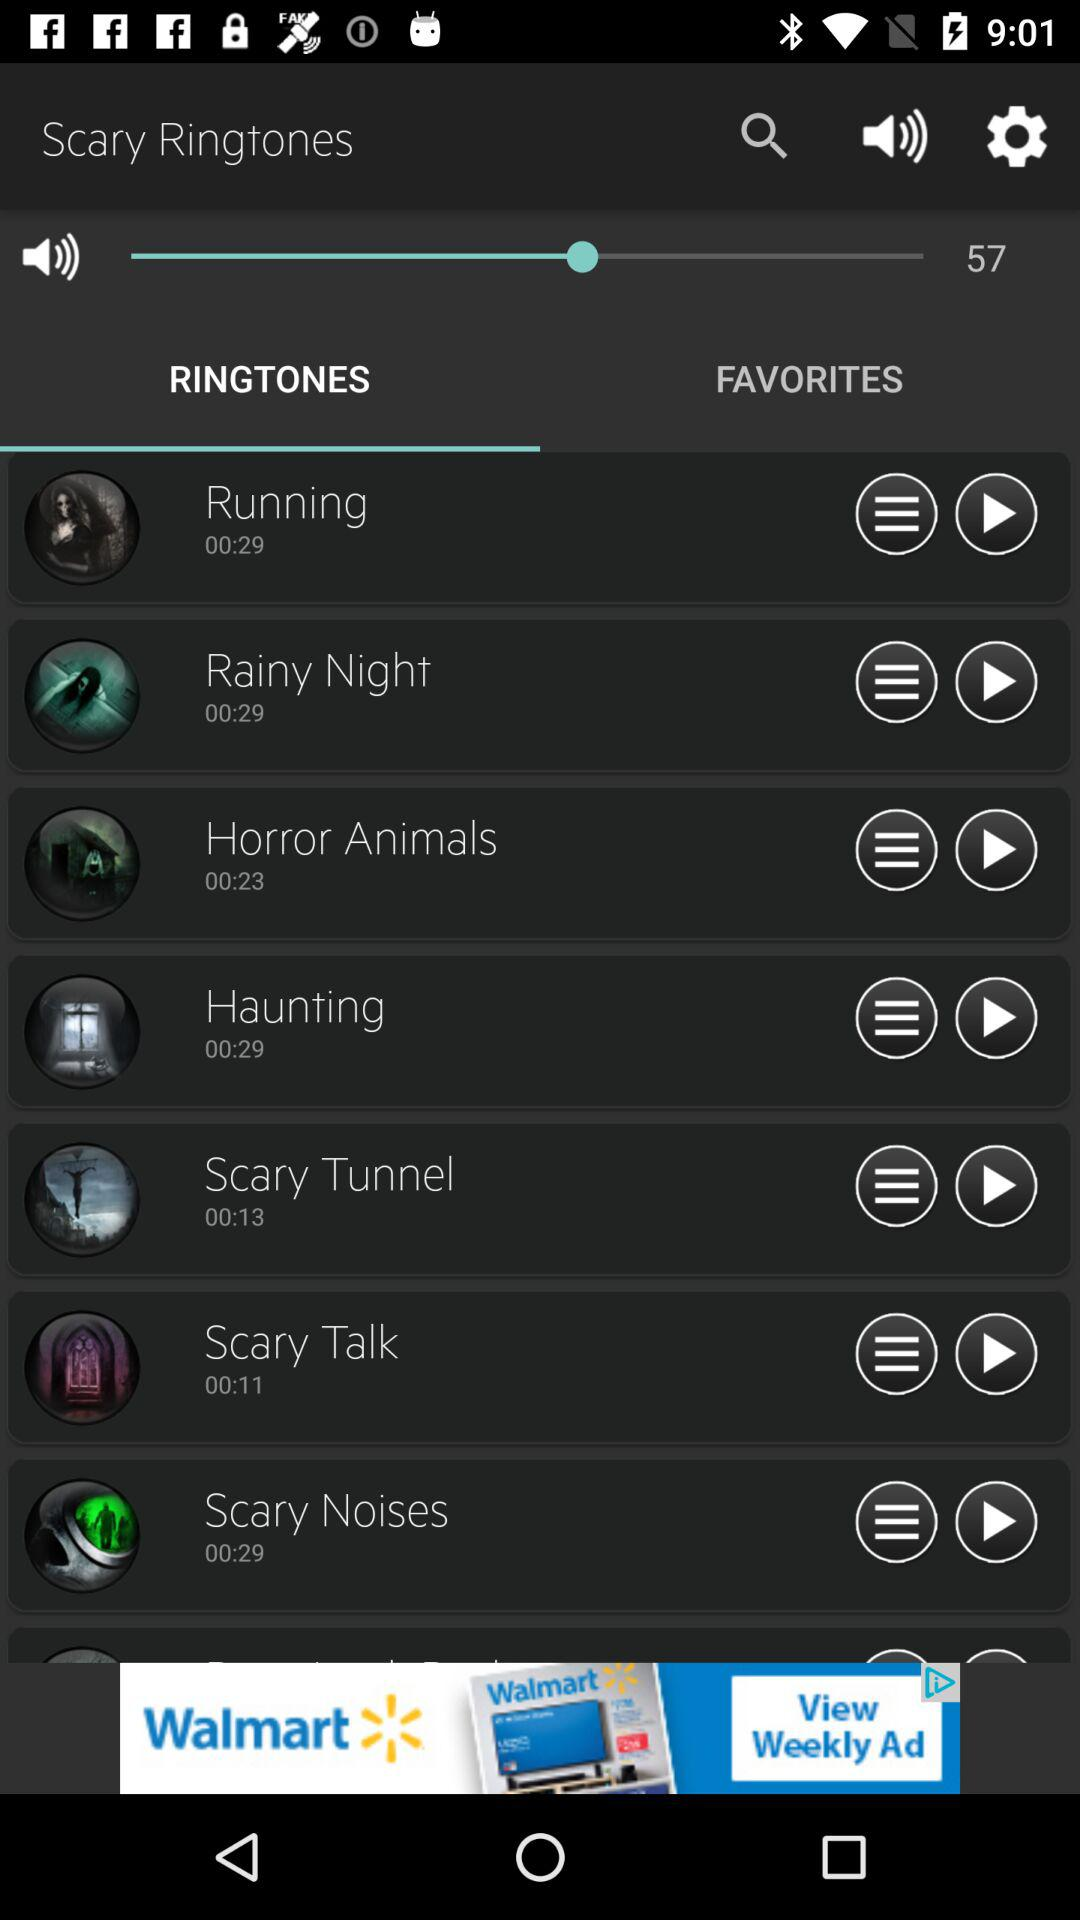What are the different available options in "Scary Ringtones"? The different available options in "Scary Ringtones" are "Running", "Rainy Night", "Horror Animals", "Haunting", "Scary Tunnel", "Scary Talk" and "Scary Noises". 